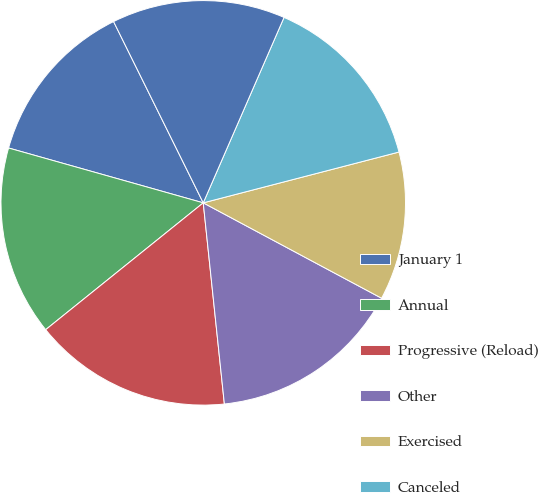Convert chart to OTSL. <chart><loc_0><loc_0><loc_500><loc_500><pie_chart><fcel>January 1<fcel>Annual<fcel>Progressive (Reload)<fcel>Other<fcel>Exercised<fcel>Canceled<fcel>December 31<nl><fcel>13.32%<fcel>15.16%<fcel>15.88%<fcel>15.52%<fcel>11.86%<fcel>14.42%<fcel>13.85%<nl></chart> 